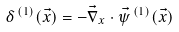<formula> <loc_0><loc_0><loc_500><loc_500>\delta ^ { \, ( 1 ) } ( \vec { x } ) = - \vec { \nabla } _ { x } \cdot \vec { \psi } ^ { \, ( 1 ) } ( \vec { x } )</formula> 